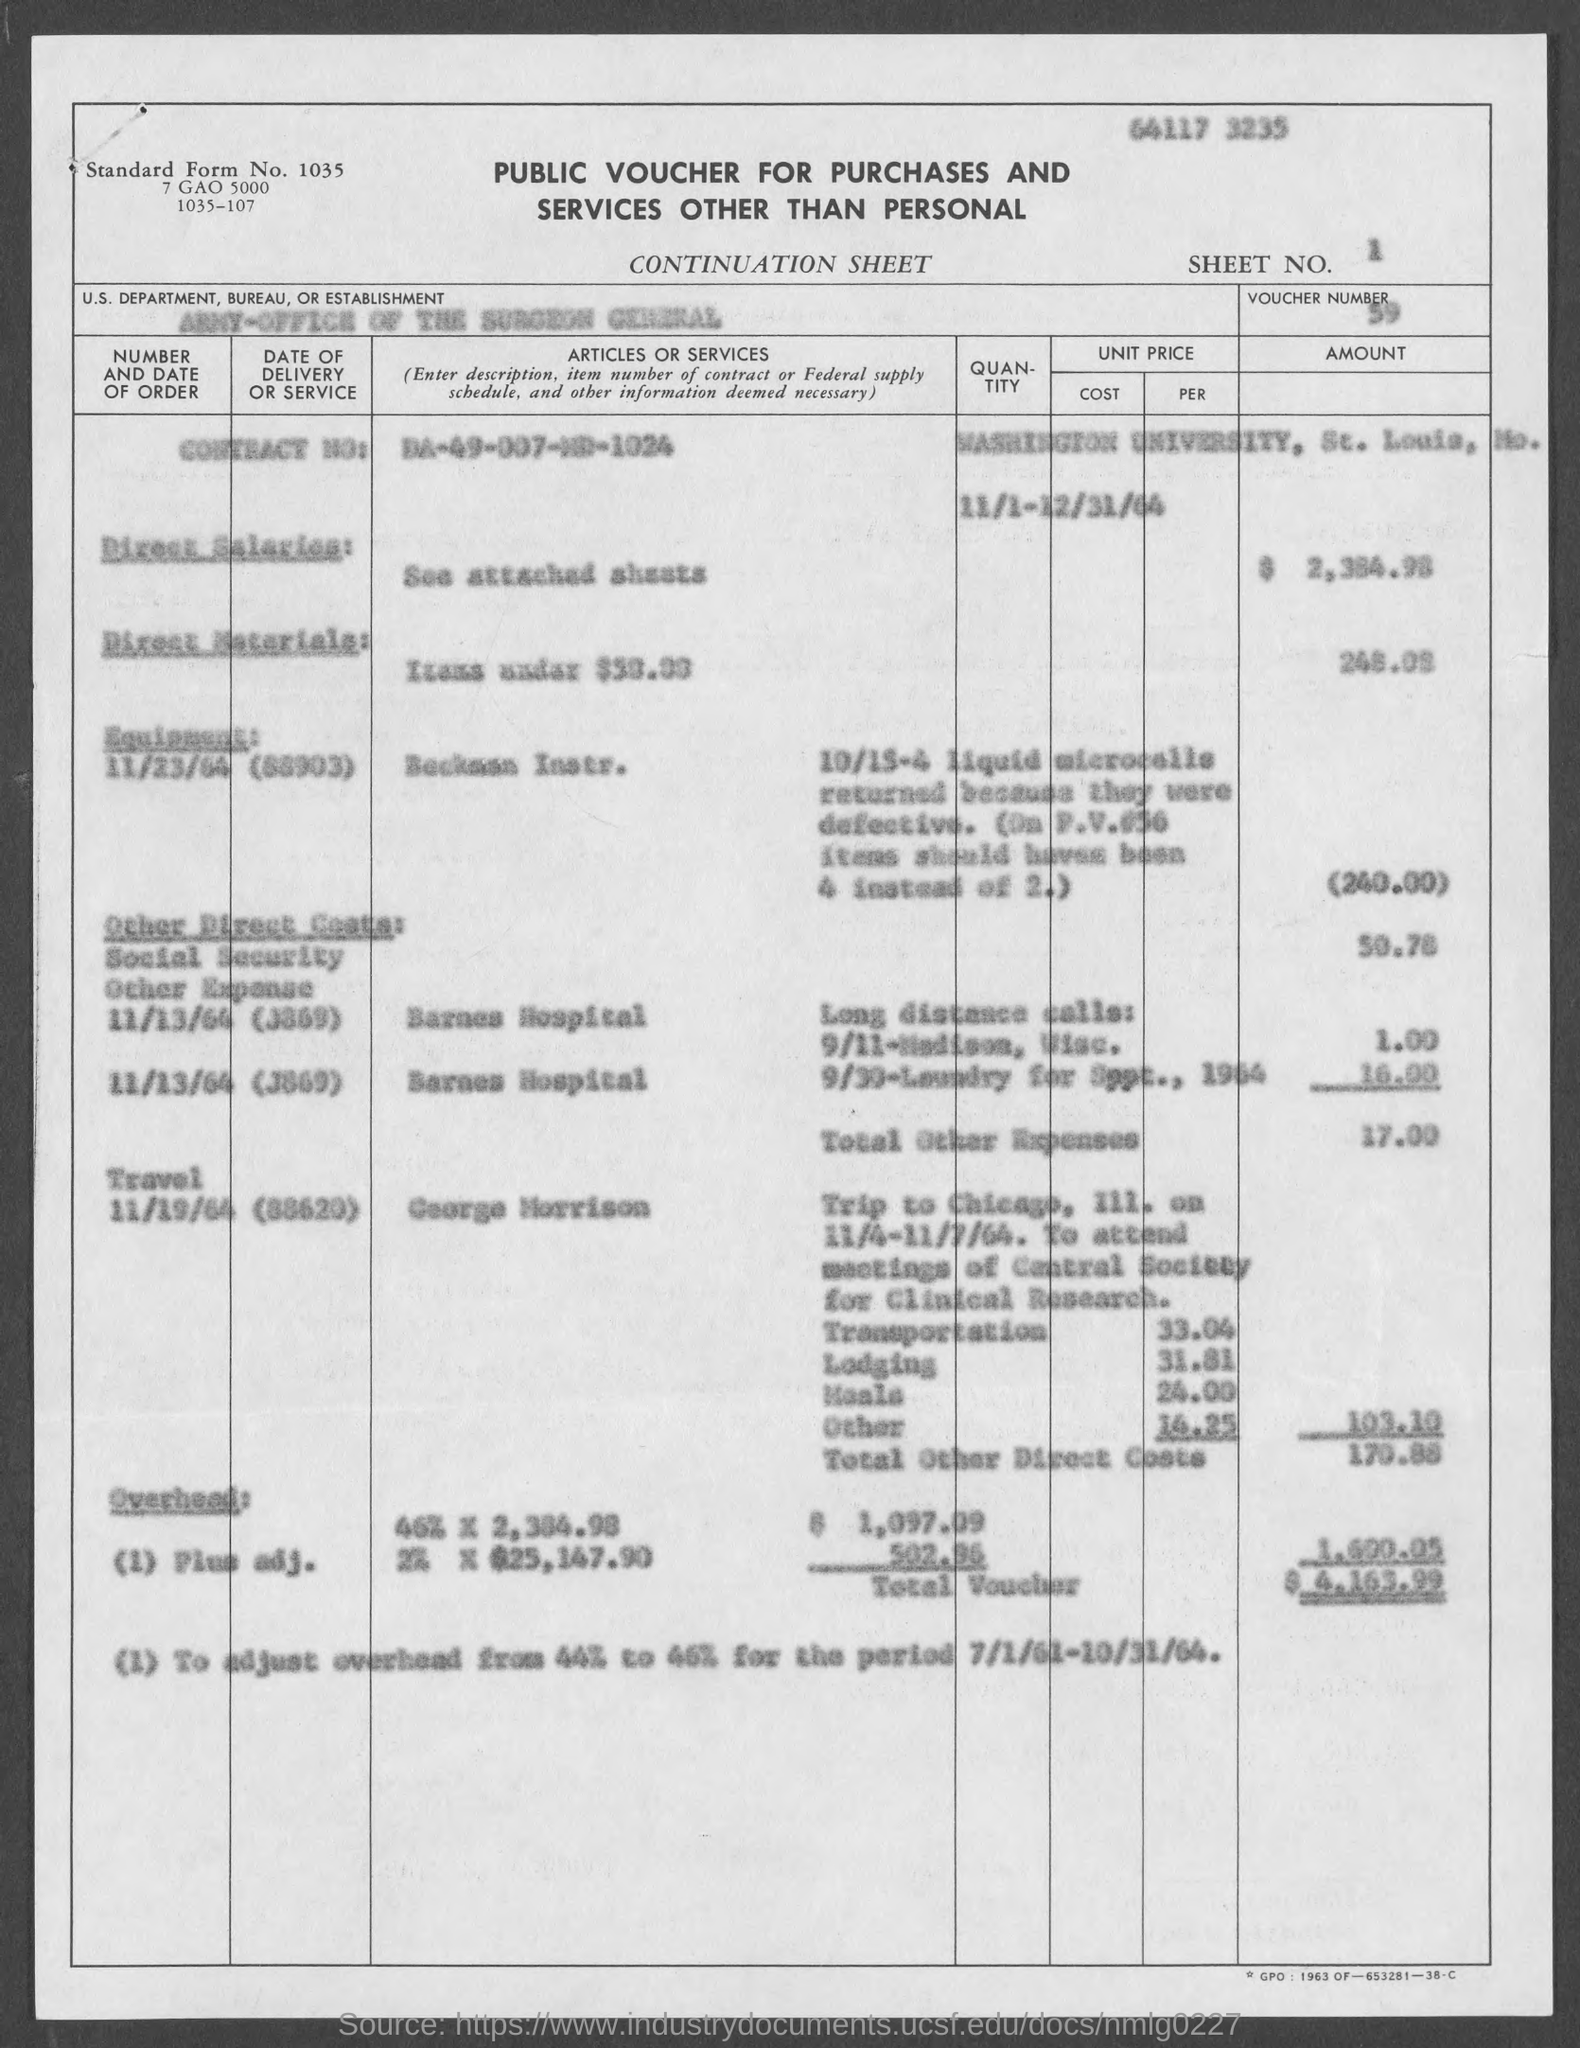What is the Standard Form No. given in the document?
Make the answer very short. 1035. What is the Sheet No. mentioned in the voucher?
Make the answer very short. 1. What is the U.S. Department, Bureau, or Establishment given in the voucher?
Give a very brief answer. ARMY-OFFICE OF THE SURGEON GENERAL. What is the voucher number given in the document?
Ensure brevity in your answer.  59. What is the Contract No. given in the voucher?
Make the answer very short. DA-49-007-MD-1024. 